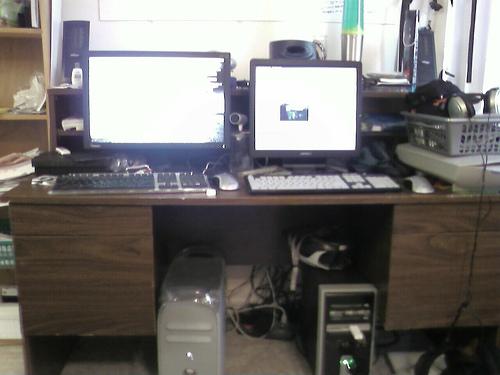Is this  room tidy?
Give a very brief answer. No. How many monitors are there?
Concise answer only. 2. What are the computers used for?
Concise answer only. Gaming. 